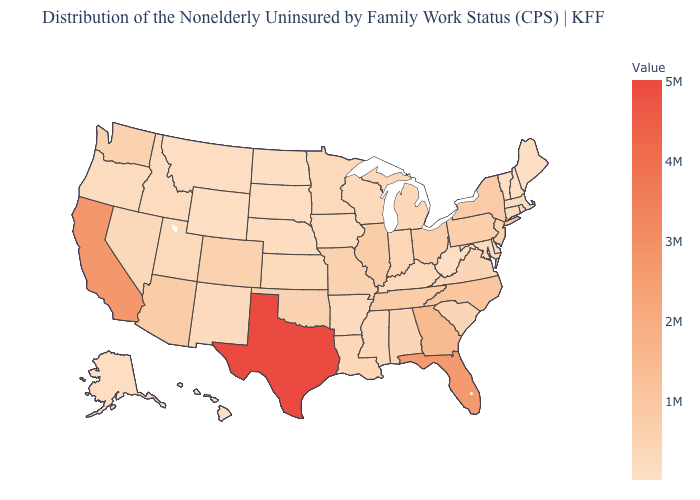Among the states that border Nevada , does California have the highest value?
Give a very brief answer. Yes. Which states hav the highest value in the West?
Quick response, please. California. Which states hav the highest value in the MidWest?
Quick response, please. Illinois. Among the states that border Arkansas , does Louisiana have the highest value?
Answer briefly. No. Among the states that border New Hampshire , which have the highest value?
Quick response, please. Massachusetts. Which states hav the highest value in the Northeast?
Keep it brief. New York. 